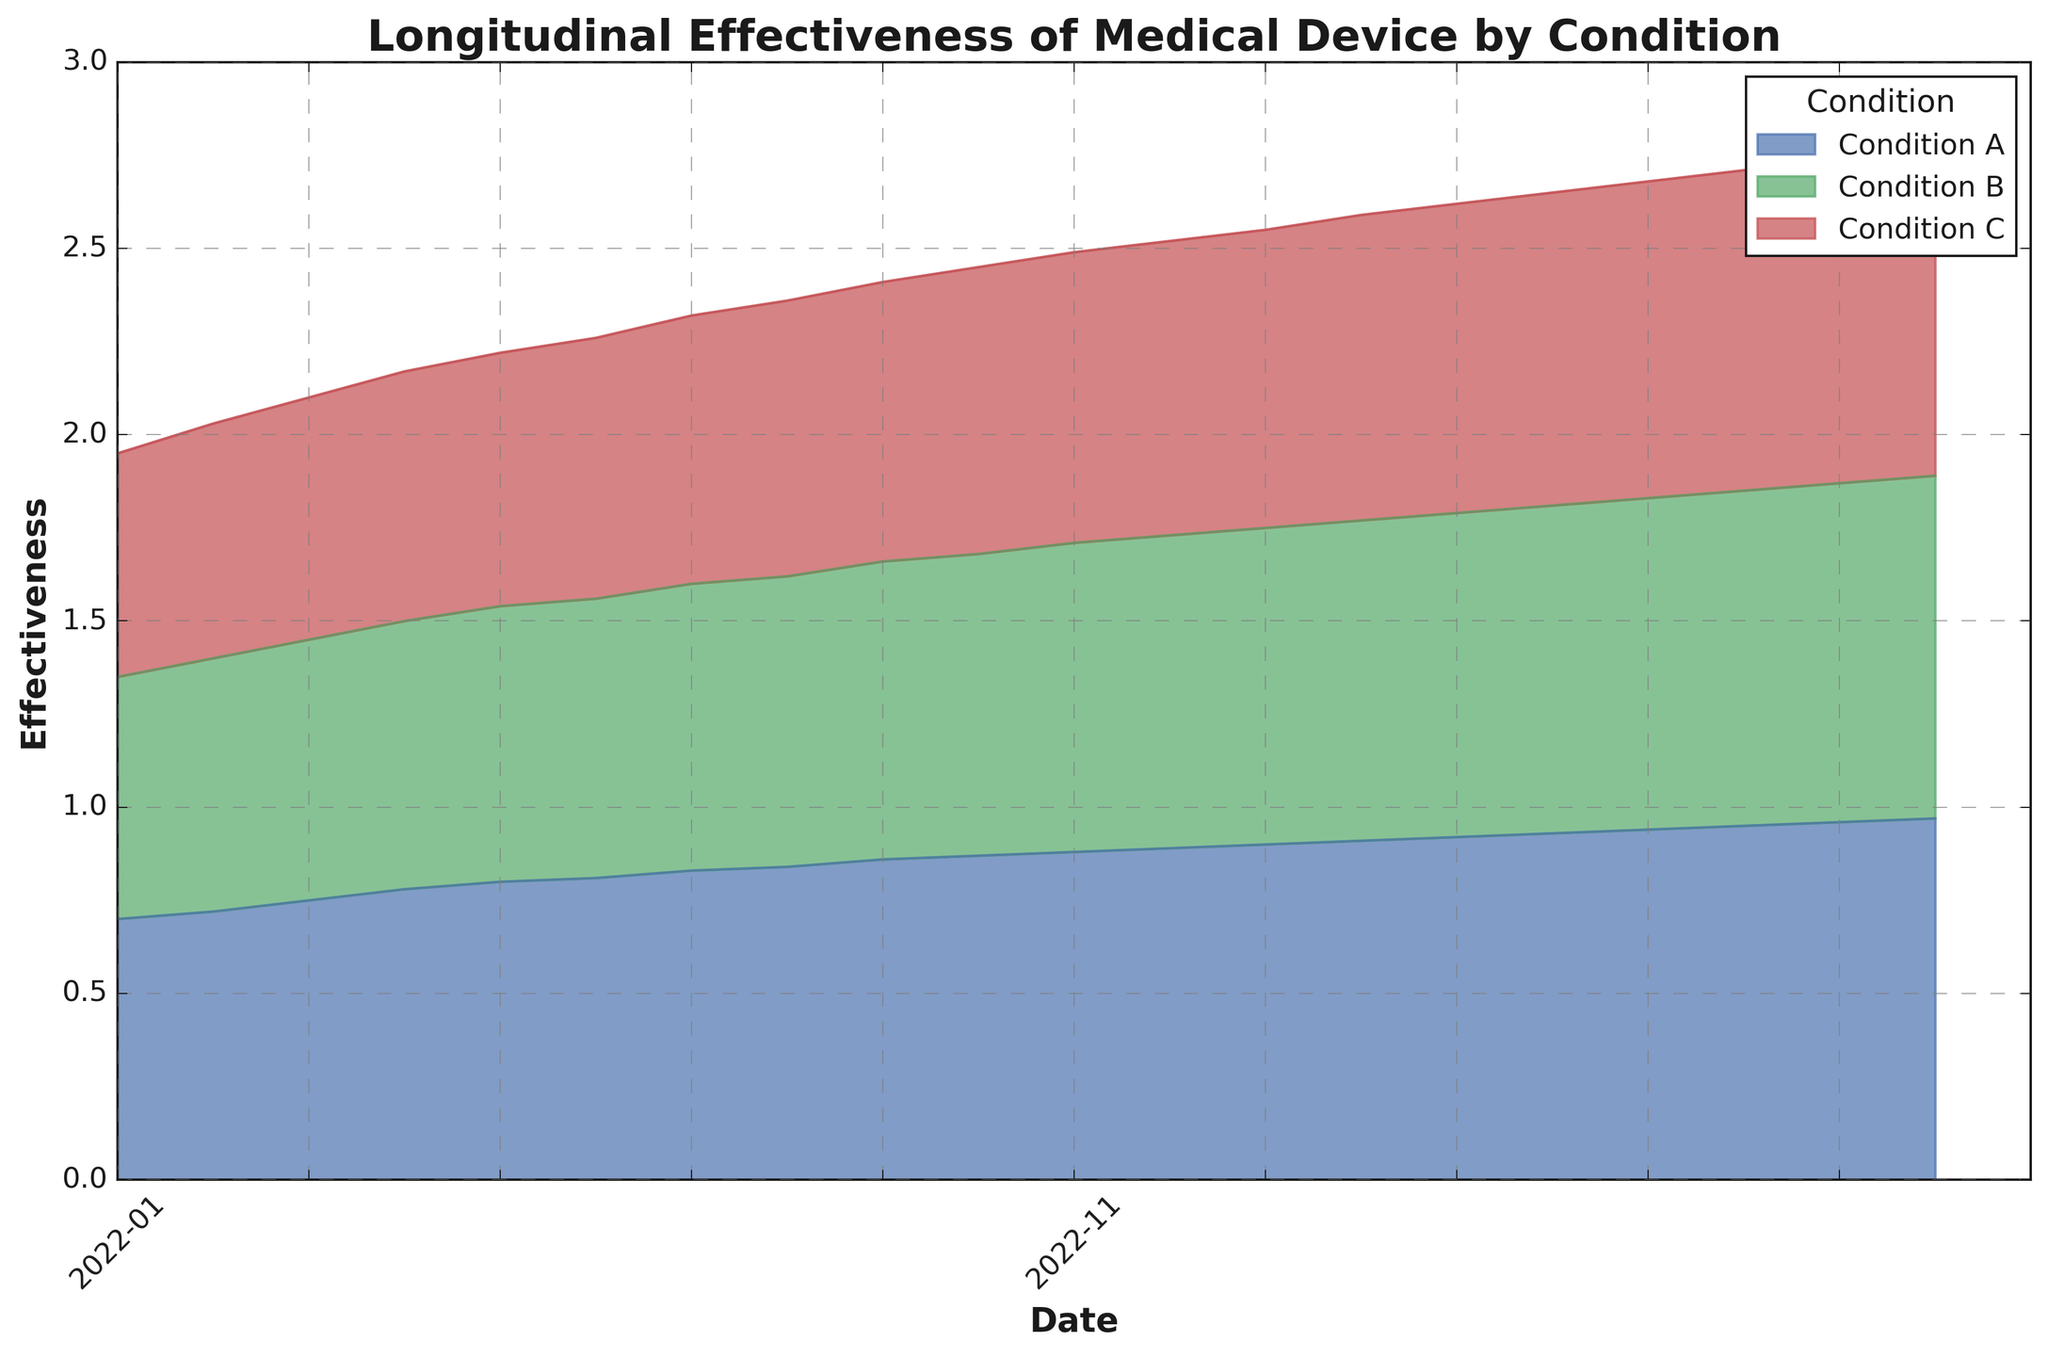What is the overall trend of effectiveness for Condition A over the entire time period? The effectiveness for Condition A steadily increases throughout the specified period from 0.70 in January 2022 to 0.97 in August 2023.
Answer: Steadily increases Which condition shows the lowest effectiveness in January 2022? By observing the starting points in January 2022, Condition C has the lowest effectiveness at 0.60.
Answer: Condition C At which month the effectiveness of Condition B first reaches 0.80? Effectiveness of Condition B first reaches 0.80 in September 2022.
Answer: September 2022 How much did the effectiveness of Condition C increase from January 2022 to August 2023? The effectiveness of Condition C in January 2022 is 0.60, and by August 2023, it is 0.88. The increase is 0.88 - 0.60 = 0.28.
Answer: 0.28 What is the average effectiveness of Condition B over the first six months of 2022? Effectiveness of Condition B from January to June 2022 are: 0.65, 0.68, 0.70, 0.72, 0.74, and 0.75. The sum is 0.65 + 0.68 + 0.70 + 0.72 + 0.74 + 0.75 = 4.24, and the average is 4.24 / 6 = 0.707.
Answer: 0.707 When did Condition A, B, and C all cross the 0.80 effectiveness threshold? Condition A crossed first in March 2022, Condition B in September 2022, and Condition C in March 2023.
Answer: March 2023 Which condition had the greatest effectiveness improvement from the initial to the final month? Condition A improved from 0.70 to 0.97, an increase of 0.27. Condition B improved from 0.65 to 0.92, an increase of 0.27. Condition C improved from 0.60 to 0.88, an increase of 0.28.
Answer: Condition C In which month do Conditions A and B show the same effectiveness? By checking the plotted data, both conditions show the same effectiveness of 0.86 in February 2023.
Answer: February 2023 